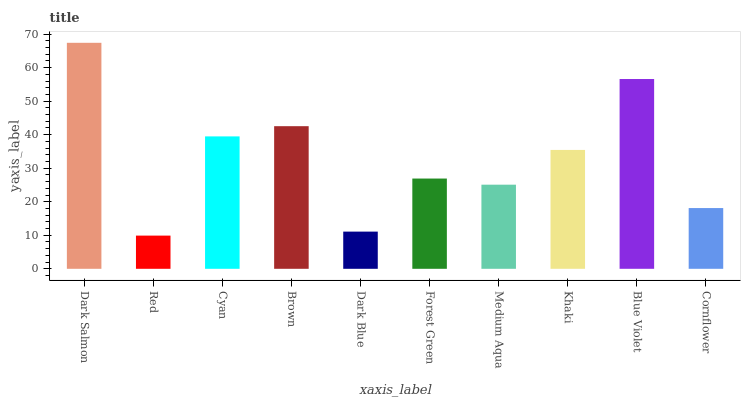Is Cyan the minimum?
Answer yes or no. No. Is Cyan the maximum?
Answer yes or no. No. Is Cyan greater than Red?
Answer yes or no. Yes. Is Red less than Cyan?
Answer yes or no. Yes. Is Red greater than Cyan?
Answer yes or no. No. Is Cyan less than Red?
Answer yes or no. No. Is Khaki the high median?
Answer yes or no. Yes. Is Forest Green the low median?
Answer yes or no. Yes. Is Brown the high median?
Answer yes or no. No. Is Cornflower the low median?
Answer yes or no. No. 